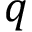Convert formula to latex. <formula><loc_0><loc_0><loc_500><loc_500>q</formula> 